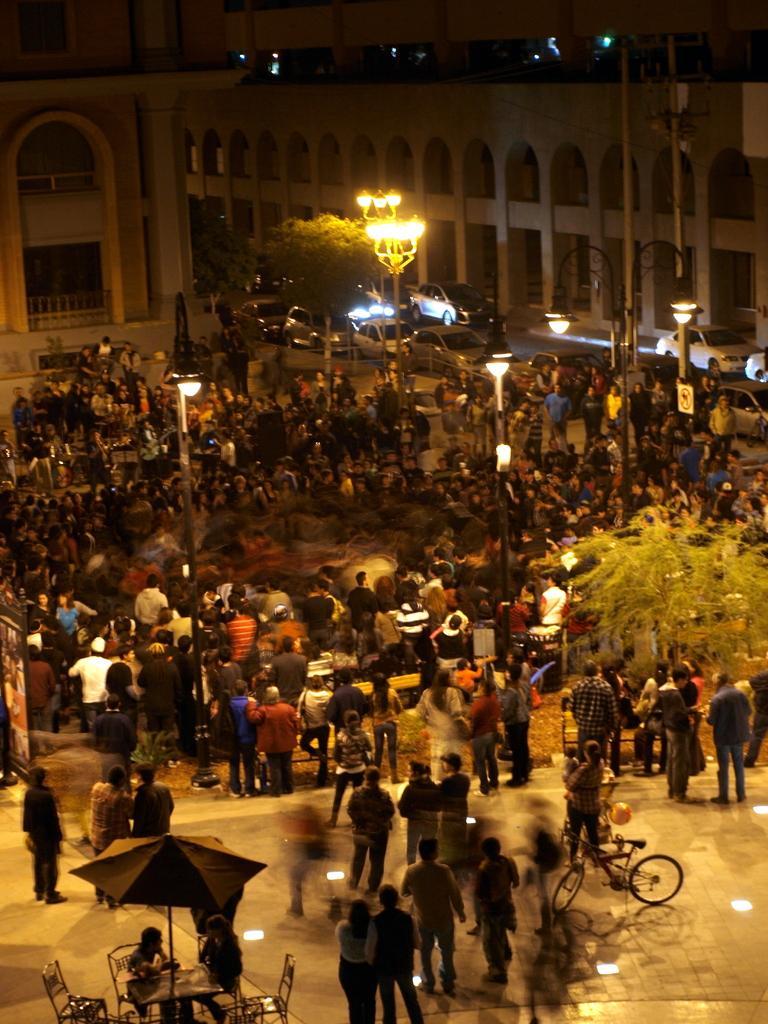In one or two sentences, can you explain what this image depicts? This picture is clicked to outside. In the foreground we can see the group of persons, trees, bicycles, table, chairs, umbrella, lights attached to the poles and we can see the buildings and vehicles and many other objects. 